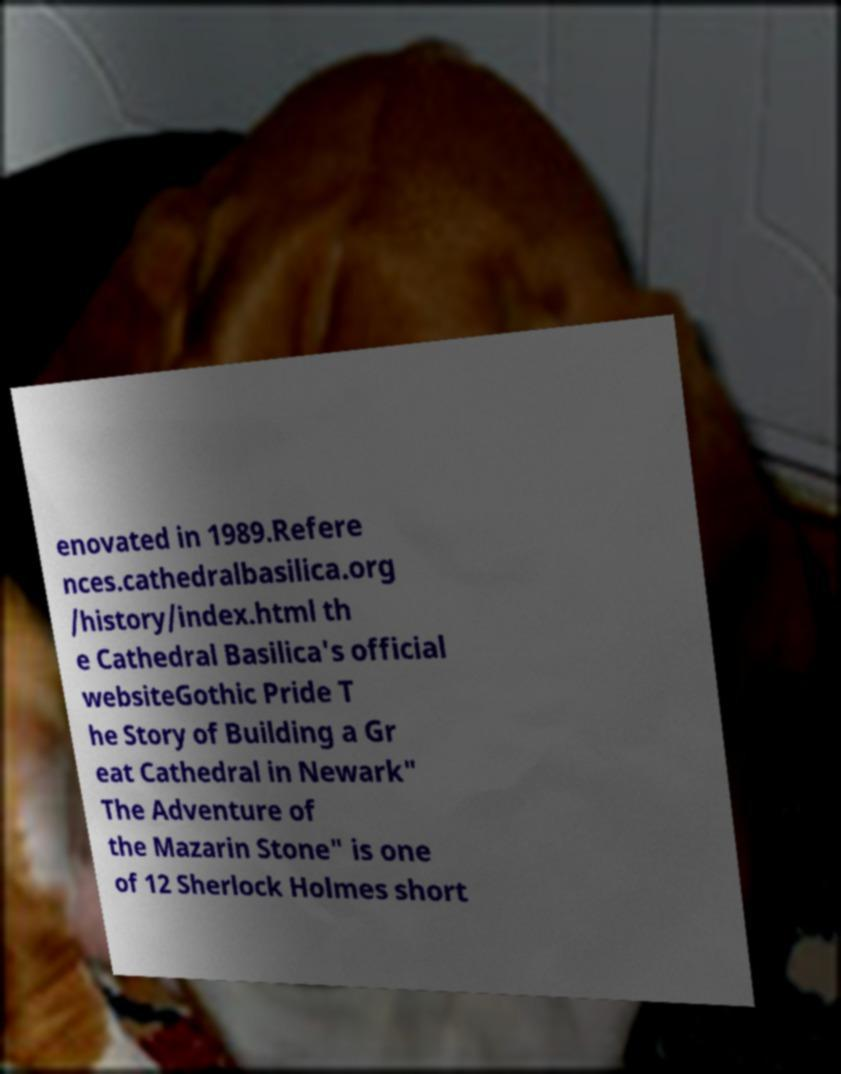There's text embedded in this image that I need extracted. Can you transcribe it verbatim? enovated in 1989.Refere nces.cathedralbasilica.org /history/index.html th e Cathedral Basilica's official websiteGothic Pride T he Story of Building a Gr eat Cathedral in Newark" The Adventure of the Mazarin Stone" is one of 12 Sherlock Holmes short 